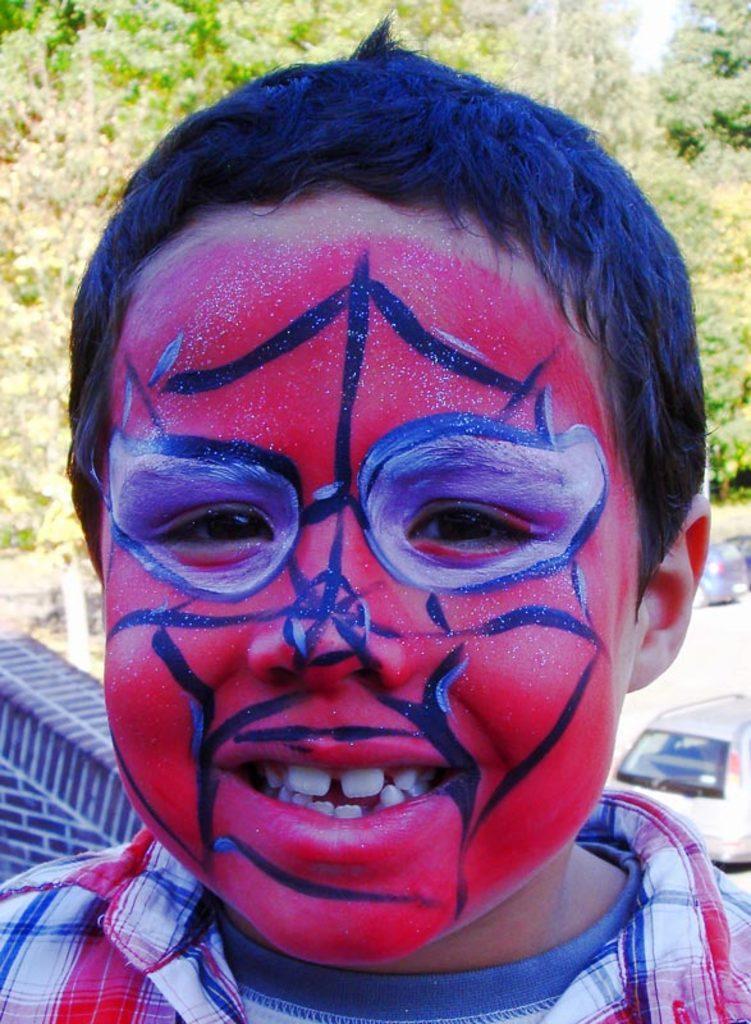In one or two sentences, can you explain what this image depicts? In the center of the image a boy is present. In the middle of the image we can see cars, road are there. At the top of the image trees are present. 